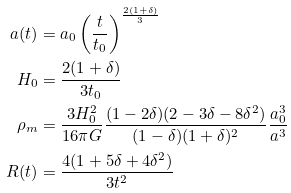Convert formula to latex. <formula><loc_0><loc_0><loc_500><loc_500>a ( t ) & = a _ { 0 } \left ( \frac { t } { t _ { 0 } } \right ) ^ { \frac { 2 ( 1 + \delta ) } { 3 } } \\ H _ { 0 } & = \frac { 2 ( 1 + \delta ) } { 3 t _ { 0 } } \\ \rho _ { m } & = \frac { 3 H _ { 0 } ^ { 2 } } { 1 6 \pi G } \frac { ( 1 - 2 \delta ) ( 2 - 3 \delta - 8 \delta ^ { 2 } ) } { ( 1 - \delta ) ( 1 + \delta ) ^ { 2 } } \frac { a _ { 0 } ^ { 3 } } { a ^ { 3 } } \\ R ( t ) & = \frac { 4 ( 1 + 5 \delta + 4 \delta ^ { 2 } ) } { 3 t ^ { 2 } }</formula> 